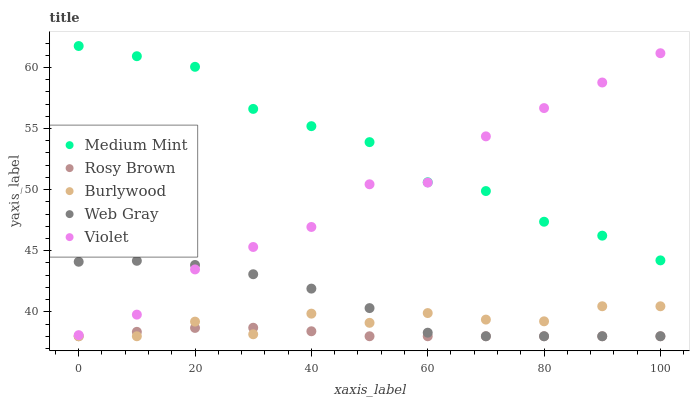Does Rosy Brown have the minimum area under the curve?
Answer yes or no. Yes. Does Medium Mint have the maximum area under the curve?
Answer yes or no. Yes. Does Burlywood have the minimum area under the curve?
Answer yes or no. No. Does Burlywood have the maximum area under the curve?
Answer yes or no. No. Is Rosy Brown the smoothest?
Answer yes or no. Yes. Is Violet the roughest?
Answer yes or no. Yes. Is Burlywood the smoothest?
Answer yes or no. No. Is Burlywood the roughest?
Answer yes or no. No. Does Burlywood have the lowest value?
Answer yes or no. Yes. Does Violet have the lowest value?
Answer yes or no. No. Does Medium Mint have the highest value?
Answer yes or no. Yes. Does Burlywood have the highest value?
Answer yes or no. No. Is Rosy Brown less than Violet?
Answer yes or no. Yes. Is Medium Mint greater than Web Gray?
Answer yes or no. Yes. Does Rosy Brown intersect Web Gray?
Answer yes or no. Yes. Is Rosy Brown less than Web Gray?
Answer yes or no. No. Is Rosy Brown greater than Web Gray?
Answer yes or no. No. Does Rosy Brown intersect Violet?
Answer yes or no. No. 